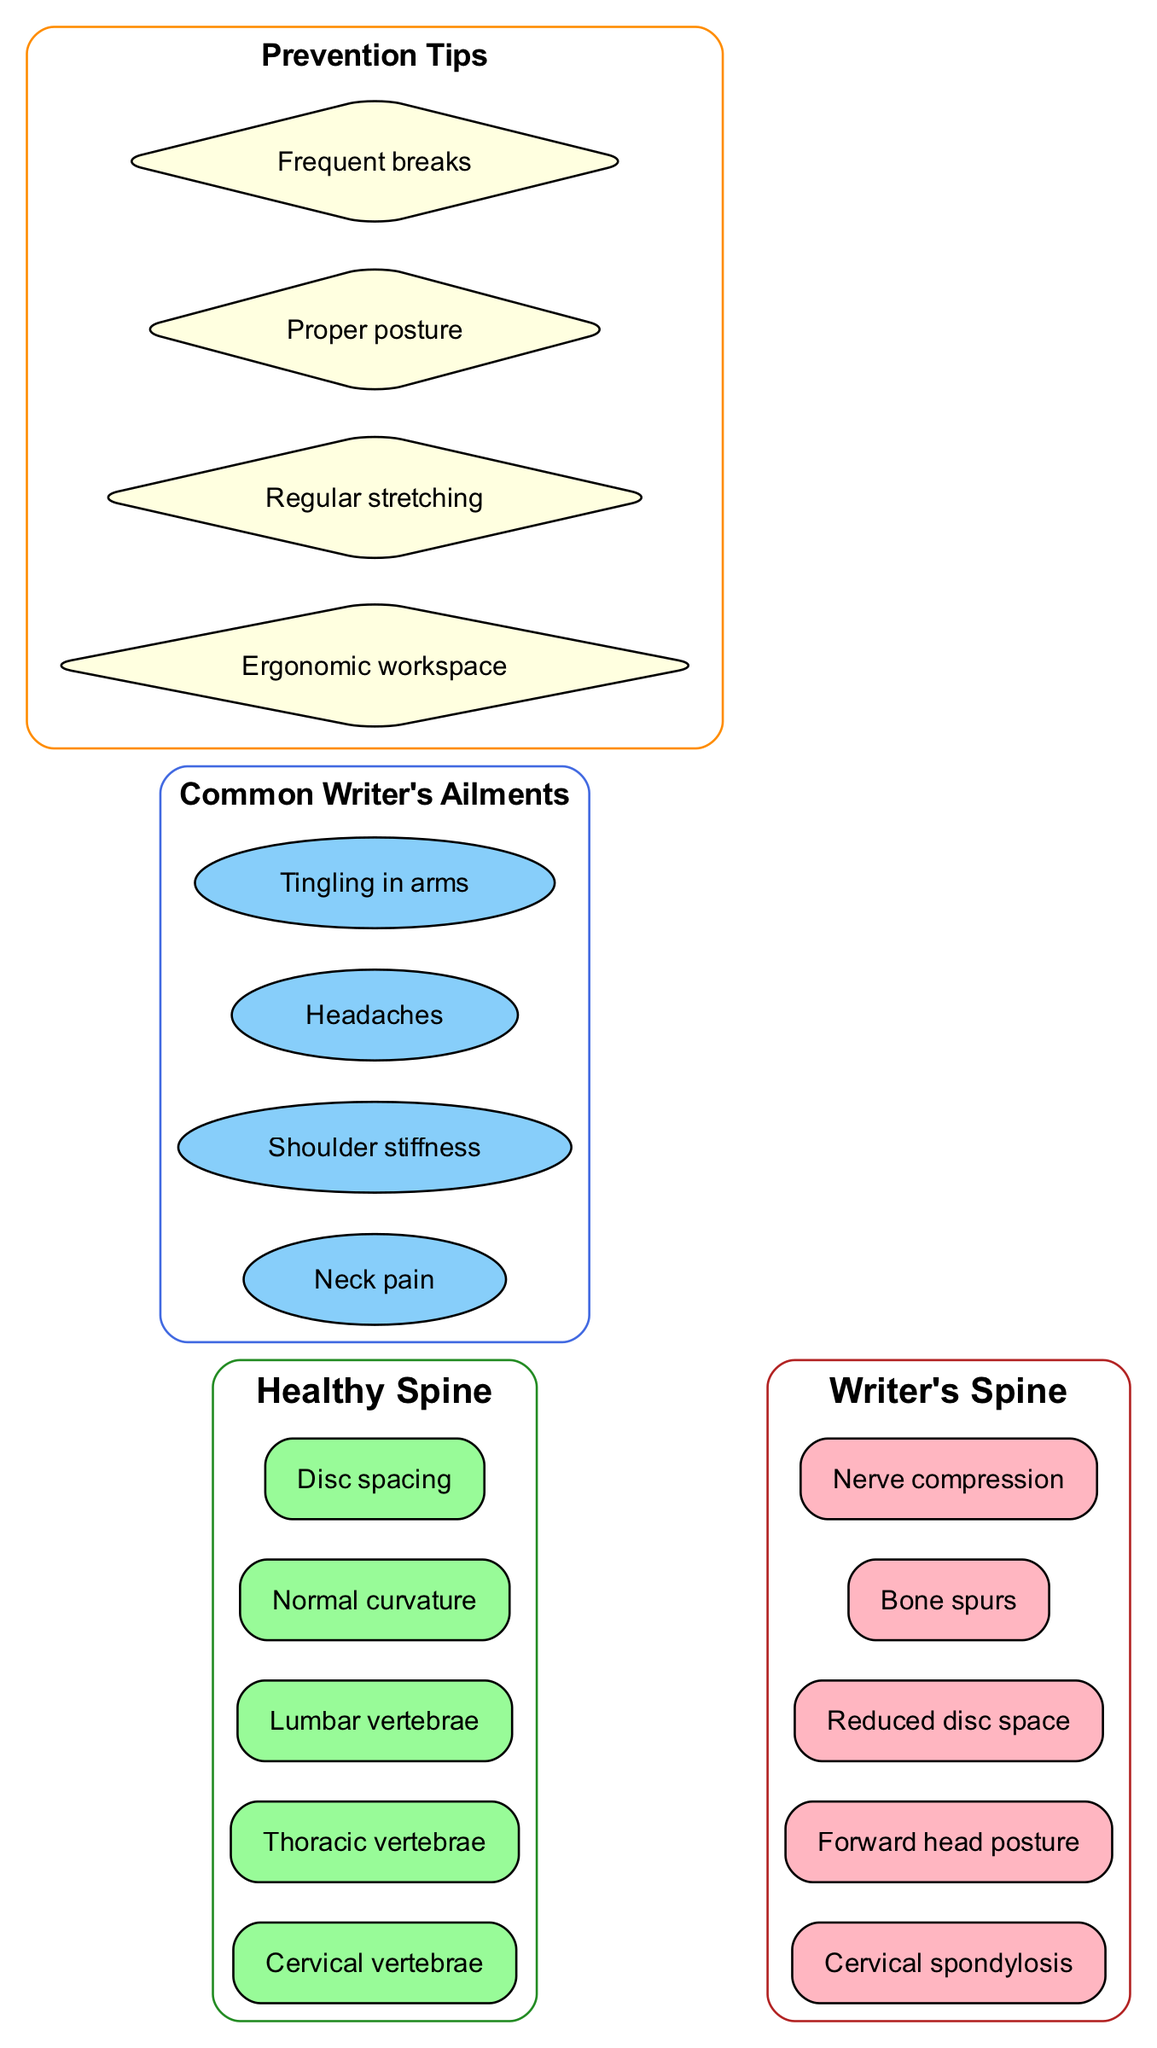What are the components of a healthy spine? The diagram lists five components under "Healthy Spine": Cervical vertebrae, Thoracic vertebrae, Lumbar vertebrae, Normal curvature, and Disc spacing.
Answer: Cervical vertebrae, Thoracic vertebrae, Lumbar vertebrae, Normal curvature, Disc spacing What conditions are illustrated under the writer's spine? The "Writer's Spine" section of the diagram contains five components: Cervical spondylosis, Forward head posture, Reduced disc space, Bone spurs, and Nerve compression.
Answer: Cervical spondylosis, Forward head posture, Reduced disc space, Bone spurs, Nerve compression How many common writer's ailments are listed? The "Common Writer's Ailments" section contains four items: Neck pain, Shoulder stiffness, Headaches, and Tingling in arms. Thus, there are four ailments.
Answer: 4 What is one prevention tip provided in the diagram? The diagram includes four prevention tips, one of which is "Ergonomic workspace." This tip is aimed at preventing spine issues related to writing.
Answer: Ergonomic workspace If a person has reduced disc space, which component are they experiencing? The reduced disc space is specifically listed under the "Writer's Spine" section, indicating that this is a condition related to writer's ailments. Specifically, it's one of the problematic conditions attributed to excessive writing.
Answer: Reduced disc space How does the healthy spine relate to the writer's spine? The diagram visually presents an invisible edge connecting components of the healthy spine to the writer's spine, indicating a direct relationship where conditions from healthy to writer's spine can lead to complications if not managed.
Answer: Direct relationship What color represents the healthy spine in the diagram? The healthy spine section is colored forest green, which differentiates it from the writer's spine illustrated in firebrick color.
Answer: Forest green What shape is used to represent common writer's ailments? The common writer's ailments in the diagram are represented using the shape of an ellipse. This shape differentiates it from other elements like boxes for spine components and diamonds for prevention tips.
Answer: Ellipse 